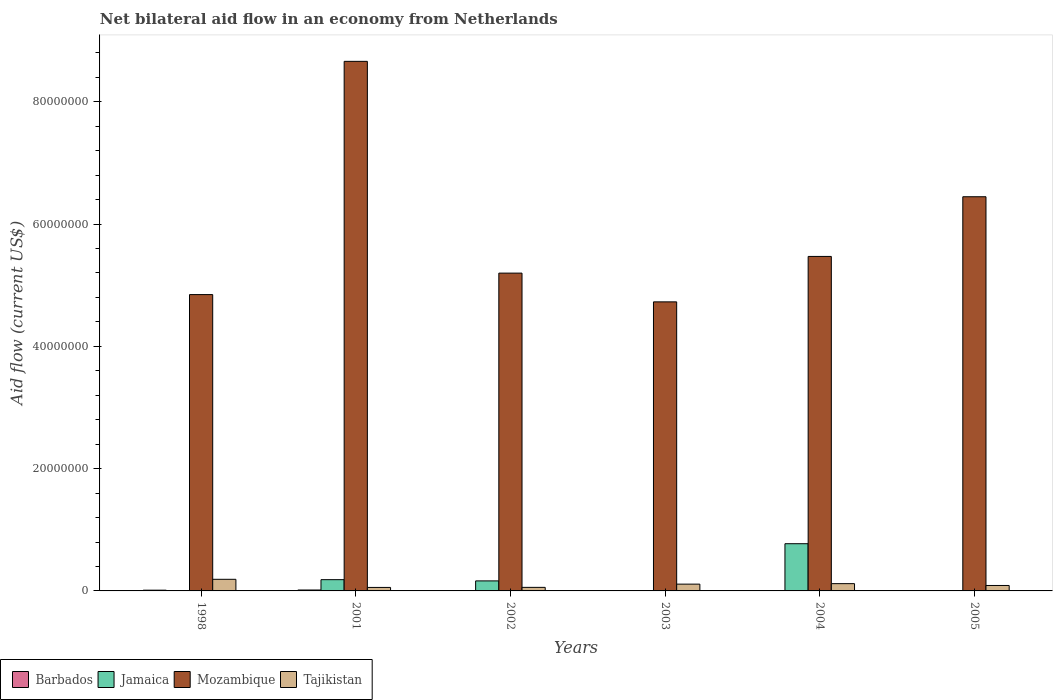How many different coloured bars are there?
Offer a terse response. 4. Are the number of bars per tick equal to the number of legend labels?
Make the answer very short. No. How many bars are there on the 3rd tick from the right?
Your answer should be compact. 3. What is the label of the 6th group of bars from the left?
Your response must be concise. 2005. What is the net bilateral aid flow in Mozambique in 2004?
Provide a short and direct response. 5.47e+07. Across all years, what is the maximum net bilateral aid flow in Barbados?
Ensure brevity in your answer.  1.50e+05. Across all years, what is the minimum net bilateral aid flow in Mozambique?
Keep it short and to the point. 4.73e+07. What is the total net bilateral aid flow in Mozambique in the graph?
Offer a very short reply. 3.53e+08. What is the difference between the net bilateral aid flow in Mozambique in 2002 and that in 2003?
Give a very brief answer. 4.70e+06. What is the difference between the net bilateral aid flow in Mozambique in 2005 and the net bilateral aid flow in Jamaica in 2004?
Your answer should be very brief. 5.67e+07. What is the average net bilateral aid flow in Jamaica per year?
Make the answer very short. 1.87e+06. In the year 2002, what is the difference between the net bilateral aid flow in Jamaica and net bilateral aid flow in Barbados?
Your answer should be compact. 1.62e+06. In how many years, is the net bilateral aid flow in Jamaica greater than 40000000 US$?
Provide a succinct answer. 0. What is the ratio of the net bilateral aid flow in Mozambique in 2004 to that in 2005?
Provide a succinct answer. 0.85. Is the net bilateral aid flow in Tajikistan in 1998 less than that in 2002?
Offer a very short reply. No. What is the difference between the highest and the second highest net bilateral aid flow in Mozambique?
Give a very brief answer. 2.21e+07. What is the difference between the highest and the lowest net bilateral aid flow in Barbados?
Make the answer very short. 1.40e+05. In how many years, is the net bilateral aid flow in Jamaica greater than the average net bilateral aid flow in Jamaica taken over all years?
Keep it short and to the point. 1. Is it the case that in every year, the sum of the net bilateral aid flow in Jamaica and net bilateral aid flow in Mozambique is greater than the sum of net bilateral aid flow in Tajikistan and net bilateral aid flow in Barbados?
Ensure brevity in your answer.  Yes. Is it the case that in every year, the sum of the net bilateral aid flow in Tajikistan and net bilateral aid flow in Jamaica is greater than the net bilateral aid flow in Mozambique?
Give a very brief answer. No. Are all the bars in the graph horizontal?
Offer a very short reply. No. How many years are there in the graph?
Offer a very short reply. 6. Where does the legend appear in the graph?
Your answer should be compact. Bottom left. How many legend labels are there?
Your answer should be compact. 4. What is the title of the graph?
Keep it short and to the point. Net bilateral aid flow in an economy from Netherlands. Does "Middle East & North Africa (developing only)" appear as one of the legend labels in the graph?
Provide a short and direct response. No. What is the Aid flow (current US$) in Jamaica in 1998?
Offer a terse response. 0. What is the Aid flow (current US$) of Mozambique in 1998?
Provide a short and direct response. 4.85e+07. What is the Aid flow (current US$) of Tajikistan in 1998?
Give a very brief answer. 1.90e+06. What is the Aid flow (current US$) of Jamaica in 2001?
Make the answer very short. 1.84e+06. What is the Aid flow (current US$) in Mozambique in 2001?
Ensure brevity in your answer.  8.66e+07. What is the Aid flow (current US$) in Tajikistan in 2001?
Provide a short and direct response. 5.70e+05. What is the Aid flow (current US$) of Barbados in 2002?
Offer a very short reply. 2.00e+04. What is the Aid flow (current US$) of Jamaica in 2002?
Offer a very short reply. 1.64e+06. What is the Aid flow (current US$) of Mozambique in 2002?
Provide a succinct answer. 5.20e+07. What is the Aid flow (current US$) in Tajikistan in 2002?
Ensure brevity in your answer.  5.80e+05. What is the Aid flow (current US$) of Barbados in 2003?
Provide a succinct answer. 2.00e+04. What is the Aid flow (current US$) in Jamaica in 2003?
Keep it short and to the point. 0. What is the Aid flow (current US$) of Mozambique in 2003?
Make the answer very short. 4.73e+07. What is the Aid flow (current US$) in Tajikistan in 2003?
Provide a succinct answer. 1.11e+06. What is the Aid flow (current US$) in Jamaica in 2004?
Ensure brevity in your answer.  7.72e+06. What is the Aid flow (current US$) of Mozambique in 2004?
Make the answer very short. 5.47e+07. What is the Aid flow (current US$) of Tajikistan in 2004?
Your answer should be compact. 1.19e+06. What is the Aid flow (current US$) in Barbados in 2005?
Keep it short and to the point. 10000. What is the Aid flow (current US$) in Mozambique in 2005?
Provide a succinct answer. 6.45e+07. What is the Aid flow (current US$) in Tajikistan in 2005?
Provide a short and direct response. 8.90e+05. Across all years, what is the maximum Aid flow (current US$) in Barbados?
Provide a succinct answer. 1.50e+05. Across all years, what is the maximum Aid flow (current US$) in Jamaica?
Offer a terse response. 7.72e+06. Across all years, what is the maximum Aid flow (current US$) in Mozambique?
Keep it short and to the point. 8.66e+07. Across all years, what is the maximum Aid flow (current US$) in Tajikistan?
Offer a terse response. 1.90e+06. Across all years, what is the minimum Aid flow (current US$) in Barbados?
Offer a terse response. 10000. Across all years, what is the minimum Aid flow (current US$) of Jamaica?
Give a very brief answer. 0. Across all years, what is the minimum Aid flow (current US$) of Mozambique?
Ensure brevity in your answer.  4.73e+07. Across all years, what is the minimum Aid flow (current US$) in Tajikistan?
Your answer should be compact. 5.70e+05. What is the total Aid flow (current US$) of Barbados in the graph?
Give a very brief answer. 3.40e+05. What is the total Aid flow (current US$) of Jamaica in the graph?
Your response must be concise. 1.12e+07. What is the total Aid flow (current US$) in Mozambique in the graph?
Ensure brevity in your answer.  3.53e+08. What is the total Aid flow (current US$) of Tajikistan in the graph?
Your answer should be compact. 6.24e+06. What is the difference between the Aid flow (current US$) of Mozambique in 1998 and that in 2001?
Make the answer very short. -3.81e+07. What is the difference between the Aid flow (current US$) of Tajikistan in 1998 and that in 2001?
Your answer should be compact. 1.33e+06. What is the difference between the Aid flow (current US$) in Barbados in 1998 and that in 2002?
Ensure brevity in your answer.  1.00e+05. What is the difference between the Aid flow (current US$) in Mozambique in 1998 and that in 2002?
Offer a terse response. -3.51e+06. What is the difference between the Aid flow (current US$) in Tajikistan in 1998 and that in 2002?
Provide a succinct answer. 1.32e+06. What is the difference between the Aid flow (current US$) in Mozambique in 1998 and that in 2003?
Offer a terse response. 1.19e+06. What is the difference between the Aid flow (current US$) of Tajikistan in 1998 and that in 2003?
Your response must be concise. 7.90e+05. What is the difference between the Aid flow (current US$) of Mozambique in 1998 and that in 2004?
Your answer should be compact. -6.24e+06. What is the difference between the Aid flow (current US$) of Tajikistan in 1998 and that in 2004?
Offer a very short reply. 7.10e+05. What is the difference between the Aid flow (current US$) in Barbados in 1998 and that in 2005?
Offer a very short reply. 1.10e+05. What is the difference between the Aid flow (current US$) in Mozambique in 1998 and that in 2005?
Your answer should be very brief. -1.60e+07. What is the difference between the Aid flow (current US$) in Tajikistan in 1998 and that in 2005?
Ensure brevity in your answer.  1.01e+06. What is the difference between the Aid flow (current US$) in Jamaica in 2001 and that in 2002?
Your response must be concise. 2.00e+05. What is the difference between the Aid flow (current US$) of Mozambique in 2001 and that in 2002?
Keep it short and to the point. 3.46e+07. What is the difference between the Aid flow (current US$) of Mozambique in 2001 and that in 2003?
Offer a terse response. 3.93e+07. What is the difference between the Aid flow (current US$) in Tajikistan in 2001 and that in 2003?
Keep it short and to the point. -5.40e+05. What is the difference between the Aid flow (current US$) of Barbados in 2001 and that in 2004?
Keep it short and to the point. 1.30e+05. What is the difference between the Aid flow (current US$) in Jamaica in 2001 and that in 2004?
Your answer should be compact. -5.88e+06. What is the difference between the Aid flow (current US$) in Mozambique in 2001 and that in 2004?
Give a very brief answer. 3.19e+07. What is the difference between the Aid flow (current US$) of Tajikistan in 2001 and that in 2004?
Offer a very short reply. -6.20e+05. What is the difference between the Aid flow (current US$) in Barbados in 2001 and that in 2005?
Offer a very short reply. 1.40e+05. What is the difference between the Aid flow (current US$) of Mozambique in 2001 and that in 2005?
Keep it short and to the point. 2.21e+07. What is the difference between the Aid flow (current US$) in Tajikistan in 2001 and that in 2005?
Provide a short and direct response. -3.20e+05. What is the difference between the Aid flow (current US$) in Barbados in 2002 and that in 2003?
Give a very brief answer. 0. What is the difference between the Aid flow (current US$) of Mozambique in 2002 and that in 2003?
Your response must be concise. 4.70e+06. What is the difference between the Aid flow (current US$) of Tajikistan in 2002 and that in 2003?
Give a very brief answer. -5.30e+05. What is the difference between the Aid flow (current US$) of Barbados in 2002 and that in 2004?
Give a very brief answer. 0. What is the difference between the Aid flow (current US$) in Jamaica in 2002 and that in 2004?
Offer a terse response. -6.08e+06. What is the difference between the Aid flow (current US$) in Mozambique in 2002 and that in 2004?
Your response must be concise. -2.73e+06. What is the difference between the Aid flow (current US$) of Tajikistan in 2002 and that in 2004?
Your answer should be very brief. -6.10e+05. What is the difference between the Aid flow (current US$) in Mozambique in 2002 and that in 2005?
Your answer should be compact. -1.25e+07. What is the difference between the Aid flow (current US$) in Tajikistan in 2002 and that in 2005?
Keep it short and to the point. -3.10e+05. What is the difference between the Aid flow (current US$) in Mozambique in 2003 and that in 2004?
Make the answer very short. -7.43e+06. What is the difference between the Aid flow (current US$) of Mozambique in 2003 and that in 2005?
Keep it short and to the point. -1.72e+07. What is the difference between the Aid flow (current US$) of Tajikistan in 2003 and that in 2005?
Provide a succinct answer. 2.20e+05. What is the difference between the Aid flow (current US$) of Mozambique in 2004 and that in 2005?
Provide a short and direct response. -9.76e+06. What is the difference between the Aid flow (current US$) of Barbados in 1998 and the Aid flow (current US$) of Jamaica in 2001?
Offer a terse response. -1.72e+06. What is the difference between the Aid flow (current US$) of Barbados in 1998 and the Aid flow (current US$) of Mozambique in 2001?
Your answer should be very brief. -8.65e+07. What is the difference between the Aid flow (current US$) in Barbados in 1998 and the Aid flow (current US$) in Tajikistan in 2001?
Your answer should be very brief. -4.50e+05. What is the difference between the Aid flow (current US$) in Mozambique in 1998 and the Aid flow (current US$) in Tajikistan in 2001?
Provide a succinct answer. 4.79e+07. What is the difference between the Aid flow (current US$) in Barbados in 1998 and the Aid flow (current US$) in Jamaica in 2002?
Offer a terse response. -1.52e+06. What is the difference between the Aid flow (current US$) in Barbados in 1998 and the Aid flow (current US$) in Mozambique in 2002?
Your answer should be very brief. -5.18e+07. What is the difference between the Aid flow (current US$) in Barbados in 1998 and the Aid flow (current US$) in Tajikistan in 2002?
Your answer should be compact. -4.60e+05. What is the difference between the Aid flow (current US$) of Mozambique in 1998 and the Aid flow (current US$) of Tajikistan in 2002?
Offer a terse response. 4.79e+07. What is the difference between the Aid flow (current US$) of Barbados in 1998 and the Aid flow (current US$) of Mozambique in 2003?
Provide a short and direct response. -4.72e+07. What is the difference between the Aid flow (current US$) in Barbados in 1998 and the Aid flow (current US$) in Tajikistan in 2003?
Offer a terse response. -9.90e+05. What is the difference between the Aid flow (current US$) in Mozambique in 1998 and the Aid flow (current US$) in Tajikistan in 2003?
Make the answer very short. 4.74e+07. What is the difference between the Aid flow (current US$) in Barbados in 1998 and the Aid flow (current US$) in Jamaica in 2004?
Make the answer very short. -7.60e+06. What is the difference between the Aid flow (current US$) in Barbados in 1998 and the Aid flow (current US$) in Mozambique in 2004?
Give a very brief answer. -5.46e+07. What is the difference between the Aid flow (current US$) in Barbados in 1998 and the Aid flow (current US$) in Tajikistan in 2004?
Ensure brevity in your answer.  -1.07e+06. What is the difference between the Aid flow (current US$) of Mozambique in 1998 and the Aid flow (current US$) of Tajikistan in 2004?
Ensure brevity in your answer.  4.73e+07. What is the difference between the Aid flow (current US$) in Barbados in 1998 and the Aid flow (current US$) in Mozambique in 2005?
Provide a succinct answer. -6.43e+07. What is the difference between the Aid flow (current US$) of Barbados in 1998 and the Aid flow (current US$) of Tajikistan in 2005?
Give a very brief answer. -7.70e+05. What is the difference between the Aid flow (current US$) in Mozambique in 1998 and the Aid flow (current US$) in Tajikistan in 2005?
Your answer should be compact. 4.76e+07. What is the difference between the Aid flow (current US$) in Barbados in 2001 and the Aid flow (current US$) in Jamaica in 2002?
Your answer should be very brief. -1.49e+06. What is the difference between the Aid flow (current US$) in Barbados in 2001 and the Aid flow (current US$) in Mozambique in 2002?
Provide a short and direct response. -5.18e+07. What is the difference between the Aid flow (current US$) of Barbados in 2001 and the Aid flow (current US$) of Tajikistan in 2002?
Offer a very short reply. -4.30e+05. What is the difference between the Aid flow (current US$) in Jamaica in 2001 and the Aid flow (current US$) in Mozambique in 2002?
Give a very brief answer. -5.01e+07. What is the difference between the Aid flow (current US$) of Jamaica in 2001 and the Aid flow (current US$) of Tajikistan in 2002?
Keep it short and to the point. 1.26e+06. What is the difference between the Aid flow (current US$) of Mozambique in 2001 and the Aid flow (current US$) of Tajikistan in 2002?
Keep it short and to the point. 8.60e+07. What is the difference between the Aid flow (current US$) in Barbados in 2001 and the Aid flow (current US$) in Mozambique in 2003?
Your response must be concise. -4.71e+07. What is the difference between the Aid flow (current US$) in Barbados in 2001 and the Aid flow (current US$) in Tajikistan in 2003?
Your response must be concise. -9.60e+05. What is the difference between the Aid flow (current US$) in Jamaica in 2001 and the Aid flow (current US$) in Mozambique in 2003?
Your response must be concise. -4.54e+07. What is the difference between the Aid flow (current US$) of Jamaica in 2001 and the Aid flow (current US$) of Tajikistan in 2003?
Offer a very short reply. 7.30e+05. What is the difference between the Aid flow (current US$) in Mozambique in 2001 and the Aid flow (current US$) in Tajikistan in 2003?
Offer a terse response. 8.55e+07. What is the difference between the Aid flow (current US$) of Barbados in 2001 and the Aid flow (current US$) of Jamaica in 2004?
Offer a very short reply. -7.57e+06. What is the difference between the Aid flow (current US$) of Barbados in 2001 and the Aid flow (current US$) of Mozambique in 2004?
Your answer should be very brief. -5.46e+07. What is the difference between the Aid flow (current US$) in Barbados in 2001 and the Aid flow (current US$) in Tajikistan in 2004?
Offer a very short reply. -1.04e+06. What is the difference between the Aid flow (current US$) in Jamaica in 2001 and the Aid flow (current US$) in Mozambique in 2004?
Ensure brevity in your answer.  -5.29e+07. What is the difference between the Aid flow (current US$) in Jamaica in 2001 and the Aid flow (current US$) in Tajikistan in 2004?
Offer a very short reply. 6.50e+05. What is the difference between the Aid flow (current US$) in Mozambique in 2001 and the Aid flow (current US$) in Tajikistan in 2004?
Offer a terse response. 8.54e+07. What is the difference between the Aid flow (current US$) of Barbados in 2001 and the Aid flow (current US$) of Mozambique in 2005?
Provide a short and direct response. -6.43e+07. What is the difference between the Aid flow (current US$) in Barbados in 2001 and the Aid flow (current US$) in Tajikistan in 2005?
Ensure brevity in your answer.  -7.40e+05. What is the difference between the Aid flow (current US$) in Jamaica in 2001 and the Aid flow (current US$) in Mozambique in 2005?
Offer a very short reply. -6.26e+07. What is the difference between the Aid flow (current US$) in Jamaica in 2001 and the Aid flow (current US$) in Tajikistan in 2005?
Keep it short and to the point. 9.50e+05. What is the difference between the Aid flow (current US$) of Mozambique in 2001 and the Aid flow (current US$) of Tajikistan in 2005?
Your answer should be very brief. 8.57e+07. What is the difference between the Aid flow (current US$) of Barbados in 2002 and the Aid flow (current US$) of Mozambique in 2003?
Your answer should be very brief. -4.72e+07. What is the difference between the Aid flow (current US$) of Barbados in 2002 and the Aid flow (current US$) of Tajikistan in 2003?
Ensure brevity in your answer.  -1.09e+06. What is the difference between the Aid flow (current US$) in Jamaica in 2002 and the Aid flow (current US$) in Mozambique in 2003?
Your answer should be very brief. -4.56e+07. What is the difference between the Aid flow (current US$) of Jamaica in 2002 and the Aid flow (current US$) of Tajikistan in 2003?
Give a very brief answer. 5.30e+05. What is the difference between the Aid flow (current US$) of Mozambique in 2002 and the Aid flow (current US$) of Tajikistan in 2003?
Your answer should be compact. 5.09e+07. What is the difference between the Aid flow (current US$) of Barbados in 2002 and the Aid flow (current US$) of Jamaica in 2004?
Provide a succinct answer. -7.70e+06. What is the difference between the Aid flow (current US$) in Barbados in 2002 and the Aid flow (current US$) in Mozambique in 2004?
Ensure brevity in your answer.  -5.47e+07. What is the difference between the Aid flow (current US$) of Barbados in 2002 and the Aid flow (current US$) of Tajikistan in 2004?
Make the answer very short. -1.17e+06. What is the difference between the Aid flow (current US$) of Jamaica in 2002 and the Aid flow (current US$) of Mozambique in 2004?
Provide a short and direct response. -5.31e+07. What is the difference between the Aid flow (current US$) in Jamaica in 2002 and the Aid flow (current US$) in Tajikistan in 2004?
Your response must be concise. 4.50e+05. What is the difference between the Aid flow (current US$) of Mozambique in 2002 and the Aid flow (current US$) of Tajikistan in 2004?
Your answer should be compact. 5.08e+07. What is the difference between the Aid flow (current US$) in Barbados in 2002 and the Aid flow (current US$) in Mozambique in 2005?
Offer a very short reply. -6.44e+07. What is the difference between the Aid flow (current US$) of Barbados in 2002 and the Aid flow (current US$) of Tajikistan in 2005?
Your answer should be compact. -8.70e+05. What is the difference between the Aid flow (current US$) in Jamaica in 2002 and the Aid flow (current US$) in Mozambique in 2005?
Provide a short and direct response. -6.28e+07. What is the difference between the Aid flow (current US$) of Jamaica in 2002 and the Aid flow (current US$) of Tajikistan in 2005?
Provide a short and direct response. 7.50e+05. What is the difference between the Aid flow (current US$) in Mozambique in 2002 and the Aid flow (current US$) in Tajikistan in 2005?
Offer a terse response. 5.11e+07. What is the difference between the Aid flow (current US$) of Barbados in 2003 and the Aid flow (current US$) of Jamaica in 2004?
Make the answer very short. -7.70e+06. What is the difference between the Aid flow (current US$) in Barbados in 2003 and the Aid flow (current US$) in Mozambique in 2004?
Offer a very short reply. -5.47e+07. What is the difference between the Aid flow (current US$) of Barbados in 2003 and the Aid flow (current US$) of Tajikistan in 2004?
Offer a very short reply. -1.17e+06. What is the difference between the Aid flow (current US$) in Mozambique in 2003 and the Aid flow (current US$) in Tajikistan in 2004?
Make the answer very short. 4.61e+07. What is the difference between the Aid flow (current US$) of Barbados in 2003 and the Aid flow (current US$) of Mozambique in 2005?
Give a very brief answer. -6.44e+07. What is the difference between the Aid flow (current US$) of Barbados in 2003 and the Aid flow (current US$) of Tajikistan in 2005?
Your answer should be compact. -8.70e+05. What is the difference between the Aid flow (current US$) of Mozambique in 2003 and the Aid flow (current US$) of Tajikistan in 2005?
Your answer should be very brief. 4.64e+07. What is the difference between the Aid flow (current US$) of Barbados in 2004 and the Aid flow (current US$) of Mozambique in 2005?
Make the answer very short. -6.44e+07. What is the difference between the Aid flow (current US$) in Barbados in 2004 and the Aid flow (current US$) in Tajikistan in 2005?
Provide a short and direct response. -8.70e+05. What is the difference between the Aid flow (current US$) of Jamaica in 2004 and the Aid flow (current US$) of Mozambique in 2005?
Your answer should be compact. -5.67e+07. What is the difference between the Aid flow (current US$) of Jamaica in 2004 and the Aid flow (current US$) of Tajikistan in 2005?
Provide a succinct answer. 6.83e+06. What is the difference between the Aid flow (current US$) in Mozambique in 2004 and the Aid flow (current US$) in Tajikistan in 2005?
Make the answer very short. 5.38e+07. What is the average Aid flow (current US$) of Barbados per year?
Keep it short and to the point. 5.67e+04. What is the average Aid flow (current US$) of Jamaica per year?
Your answer should be very brief. 1.87e+06. What is the average Aid flow (current US$) in Mozambique per year?
Your answer should be compact. 5.89e+07. What is the average Aid flow (current US$) of Tajikistan per year?
Your response must be concise. 1.04e+06. In the year 1998, what is the difference between the Aid flow (current US$) of Barbados and Aid flow (current US$) of Mozambique?
Make the answer very short. -4.83e+07. In the year 1998, what is the difference between the Aid flow (current US$) in Barbados and Aid flow (current US$) in Tajikistan?
Your answer should be very brief. -1.78e+06. In the year 1998, what is the difference between the Aid flow (current US$) of Mozambique and Aid flow (current US$) of Tajikistan?
Provide a succinct answer. 4.66e+07. In the year 2001, what is the difference between the Aid flow (current US$) of Barbados and Aid flow (current US$) of Jamaica?
Provide a succinct answer. -1.69e+06. In the year 2001, what is the difference between the Aid flow (current US$) of Barbados and Aid flow (current US$) of Mozambique?
Your response must be concise. -8.64e+07. In the year 2001, what is the difference between the Aid flow (current US$) of Barbados and Aid flow (current US$) of Tajikistan?
Give a very brief answer. -4.20e+05. In the year 2001, what is the difference between the Aid flow (current US$) of Jamaica and Aid flow (current US$) of Mozambique?
Give a very brief answer. -8.48e+07. In the year 2001, what is the difference between the Aid flow (current US$) in Jamaica and Aid flow (current US$) in Tajikistan?
Make the answer very short. 1.27e+06. In the year 2001, what is the difference between the Aid flow (current US$) in Mozambique and Aid flow (current US$) in Tajikistan?
Provide a short and direct response. 8.60e+07. In the year 2002, what is the difference between the Aid flow (current US$) in Barbados and Aid flow (current US$) in Jamaica?
Ensure brevity in your answer.  -1.62e+06. In the year 2002, what is the difference between the Aid flow (current US$) of Barbados and Aid flow (current US$) of Mozambique?
Provide a short and direct response. -5.20e+07. In the year 2002, what is the difference between the Aid flow (current US$) of Barbados and Aid flow (current US$) of Tajikistan?
Offer a terse response. -5.60e+05. In the year 2002, what is the difference between the Aid flow (current US$) in Jamaica and Aid flow (current US$) in Mozambique?
Your answer should be very brief. -5.03e+07. In the year 2002, what is the difference between the Aid flow (current US$) in Jamaica and Aid flow (current US$) in Tajikistan?
Keep it short and to the point. 1.06e+06. In the year 2002, what is the difference between the Aid flow (current US$) in Mozambique and Aid flow (current US$) in Tajikistan?
Give a very brief answer. 5.14e+07. In the year 2003, what is the difference between the Aid flow (current US$) in Barbados and Aid flow (current US$) in Mozambique?
Provide a short and direct response. -4.72e+07. In the year 2003, what is the difference between the Aid flow (current US$) in Barbados and Aid flow (current US$) in Tajikistan?
Your response must be concise. -1.09e+06. In the year 2003, what is the difference between the Aid flow (current US$) of Mozambique and Aid flow (current US$) of Tajikistan?
Your response must be concise. 4.62e+07. In the year 2004, what is the difference between the Aid flow (current US$) in Barbados and Aid flow (current US$) in Jamaica?
Ensure brevity in your answer.  -7.70e+06. In the year 2004, what is the difference between the Aid flow (current US$) in Barbados and Aid flow (current US$) in Mozambique?
Ensure brevity in your answer.  -5.47e+07. In the year 2004, what is the difference between the Aid flow (current US$) of Barbados and Aid flow (current US$) of Tajikistan?
Your response must be concise. -1.17e+06. In the year 2004, what is the difference between the Aid flow (current US$) of Jamaica and Aid flow (current US$) of Mozambique?
Keep it short and to the point. -4.70e+07. In the year 2004, what is the difference between the Aid flow (current US$) of Jamaica and Aid flow (current US$) of Tajikistan?
Offer a very short reply. 6.53e+06. In the year 2004, what is the difference between the Aid flow (current US$) in Mozambique and Aid flow (current US$) in Tajikistan?
Ensure brevity in your answer.  5.35e+07. In the year 2005, what is the difference between the Aid flow (current US$) in Barbados and Aid flow (current US$) in Mozambique?
Provide a succinct answer. -6.44e+07. In the year 2005, what is the difference between the Aid flow (current US$) in Barbados and Aid flow (current US$) in Tajikistan?
Ensure brevity in your answer.  -8.80e+05. In the year 2005, what is the difference between the Aid flow (current US$) of Mozambique and Aid flow (current US$) of Tajikistan?
Your answer should be compact. 6.36e+07. What is the ratio of the Aid flow (current US$) of Barbados in 1998 to that in 2001?
Provide a short and direct response. 0.8. What is the ratio of the Aid flow (current US$) of Mozambique in 1998 to that in 2001?
Offer a terse response. 0.56. What is the ratio of the Aid flow (current US$) in Tajikistan in 1998 to that in 2001?
Ensure brevity in your answer.  3.33. What is the ratio of the Aid flow (current US$) in Barbados in 1998 to that in 2002?
Give a very brief answer. 6. What is the ratio of the Aid flow (current US$) in Mozambique in 1998 to that in 2002?
Offer a very short reply. 0.93. What is the ratio of the Aid flow (current US$) of Tajikistan in 1998 to that in 2002?
Your response must be concise. 3.28. What is the ratio of the Aid flow (current US$) of Mozambique in 1998 to that in 2003?
Offer a very short reply. 1.03. What is the ratio of the Aid flow (current US$) in Tajikistan in 1998 to that in 2003?
Provide a short and direct response. 1.71. What is the ratio of the Aid flow (current US$) in Mozambique in 1998 to that in 2004?
Offer a terse response. 0.89. What is the ratio of the Aid flow (current US$) in Tajikistan in 1998 to that in 2004?
Offer a terse response. 1.6. What is the ratio of the Aid flow (current US$) of Barbados in 1998 to that in 2005?
Ensure brevity in your answer.  12. What is the ratio of the Aid flow (current US$) in Mozambique in 1998 to that in 2005?
Offer a very short reply. 0.75. What is the ratio of the Aid flow (current US$) of Tajikistan in 1998 to that in 2005?
Ensure brevity in your answer.  2.13. What is the ratio of the Aid flow (current US$) in Jamaica in 2001 to that in 2002?
Provide a succinct answer. 1.12. What is the ratio of the Aid flow (current US$) of Mozambique in 2001 to that in 2002?
Ensure brevity in your answer.  1.67. What is the ratio of the Aid flow (current US$) in Tajikistan in 2001 to that in 2002?
Your answer should be very brief. 0.98. What is the ratio of the Aid flow (current US$) of Mozambique in 2001 to that in 2003?
Your answer should be compact. 1.83. What is the ratio of the Aid flow (current US$) in Tajikistan in 2001 to that in 2003?
Ensure brevity in your answer.  0.51. What is the ratio of the Aid flow (current US$) of Jamaica in 2001 to that in 2004?
Your answer should be very brief. 0.24. What is the ratio of the Aid flow (current US$) of Mozambique in 2001 to that in 2004?
Offer a terse response. 1.58. What is the ratio of the Aid flow (current US$) in Tajikistan in 2001 to that in 2004?
Your answer should be compact. 0.48. What is the ratio of the Aid flow (current US$) in Barbados in 2001 to that in 2005?
Your response must be concise. 15. What is the ratio of the Aid flow (current US$) of Mozambique in 2001 to that in 2005?
Ensure brevity in your answer.  1.34. What is the ratio of the Aid flow (current US$) of Tajikistan in 2001 to that in 2005?
Make the answer very short. 0.64. What is the ratio of the Aid flow (current US$) in Mozambique in 2002 to that in 2003?
Make the answer very short. 1.1. What is the ratio of the Aid flow (current US$) in Tajikistan in 2002 to that in 2003?
Provide a succinct answer. 0.52. What is the ratio of the Aid flow (current US$) in Jamaica in 2002 to that in 2004?
Your response must be concise. 0.21. What is the ratio of the Aid flow (current US$) in Mozambique in 2002 to that in 2004?
Offer a very short reply. 0.95. What is the ratio of the Aid flow (current US$) in Tajikistan in 2002 to that in 2004?
Ensure brevity in your answer.  0.49. What is the ratio of the Aid flow (current US$) in Mozambique in 2002 to that in 2005?
Your answer should be very brief. 0.81. What is the ratio of the Aid flow (current US$) of Tajikistan in 2002 to that in 2005?
Your answer should be compact. 0.65. What is the ratio of the Aid flow (current US$) in Mozambique in 2003 to that in 2004?
Keep it short and to the point. 0.86. What is the ratio of the Aid flow (current US$) of Tajikistan in 2003 to that in 2004?
Provide a short and direct response. 0.93. What is the ratio of the Aid flow (current US$) in Barbados in 2003 to that in 2005?
Offer a terse response. 2. What is the ratio of the Aid flow (current US$) of Mozambique in 2003 to that in 2005?
Offer a very short reply. 0.73. What is the ratio of the Aid flow (current US$) in Tajikistan in 2003 to that in 2005?
Your answer should be very brief. 1.25. What is the ratio of the Aid flow (current US$) in Mozambique in 2004 to that in 2005?
Your answer should be very brief. 0.85. What is the ratio of the Aid flow (current US$) of Tajikistan in 2004 to that in 2005?
Your answer should be compact. 1.34. What is the difference between the highest and the second highest Aid flow (current US$) in Barbados?
Your answer should be compact. 3.00e+04. What is the difference between the highest and the second highest Aid flow (current US$) of Jamaica?
Your answer should be very brief. 5.88e+06. What is the difference between the highest and the second highest Aid flow (current US$) of Mozambique?
Make the answer very short. 2.21e+07. What is the difference between the highest and the second highest Aid flow (current US$) in Tajikistan?
Ensure brevity in your answer.  7.10e+05. What is the difference between the highest and the lowest Aid flow (current US$) of Barbados?
Give a very brief answer. 1.40e+05. What is the difference between the highest and the lowest Aid flow (current US$) of Jamaica?
Make the answer very short. 7.72e+06. What is the difference between the highest and the lowest Aid flow (current US$) in Mozambique?
Make the answer very short. 3.93e+07. What is the difference between the highest and the lowest Aid flow (current US$) of Tajikistan?
Offer a terse response. 1.33e+06. 